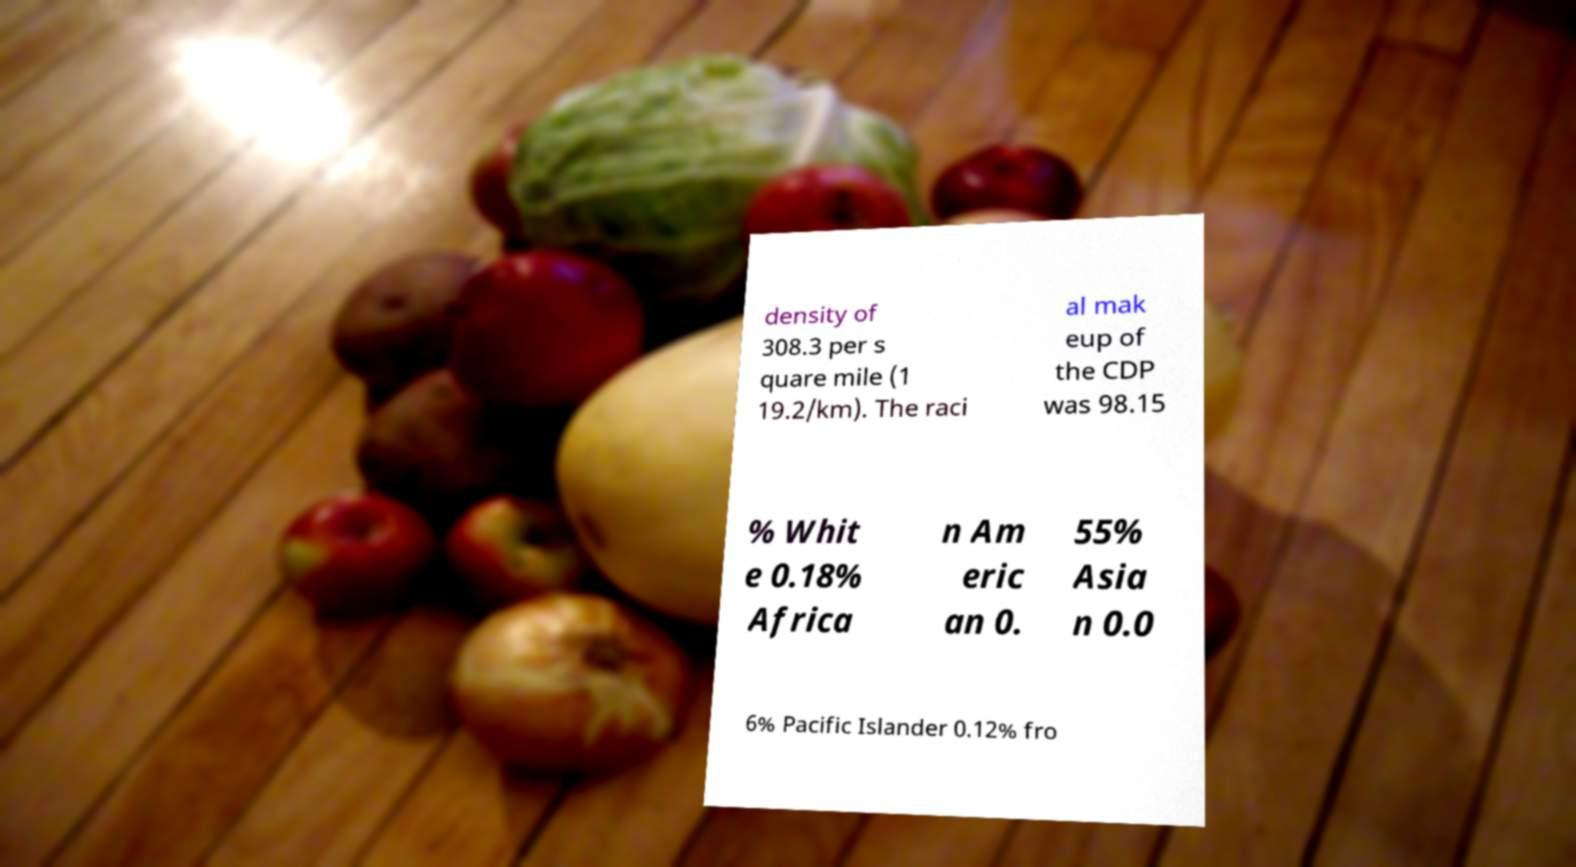Could you extract and type out the text from this image? density of 308.3 per s quare mile (1 19.2/km). The raci al mak eup of the CDP was 98.15 % Whit e 0.18% Africa n Am eric an 0. 55% Asia n 0.0 6% Pacific Islander 0.12% fro 